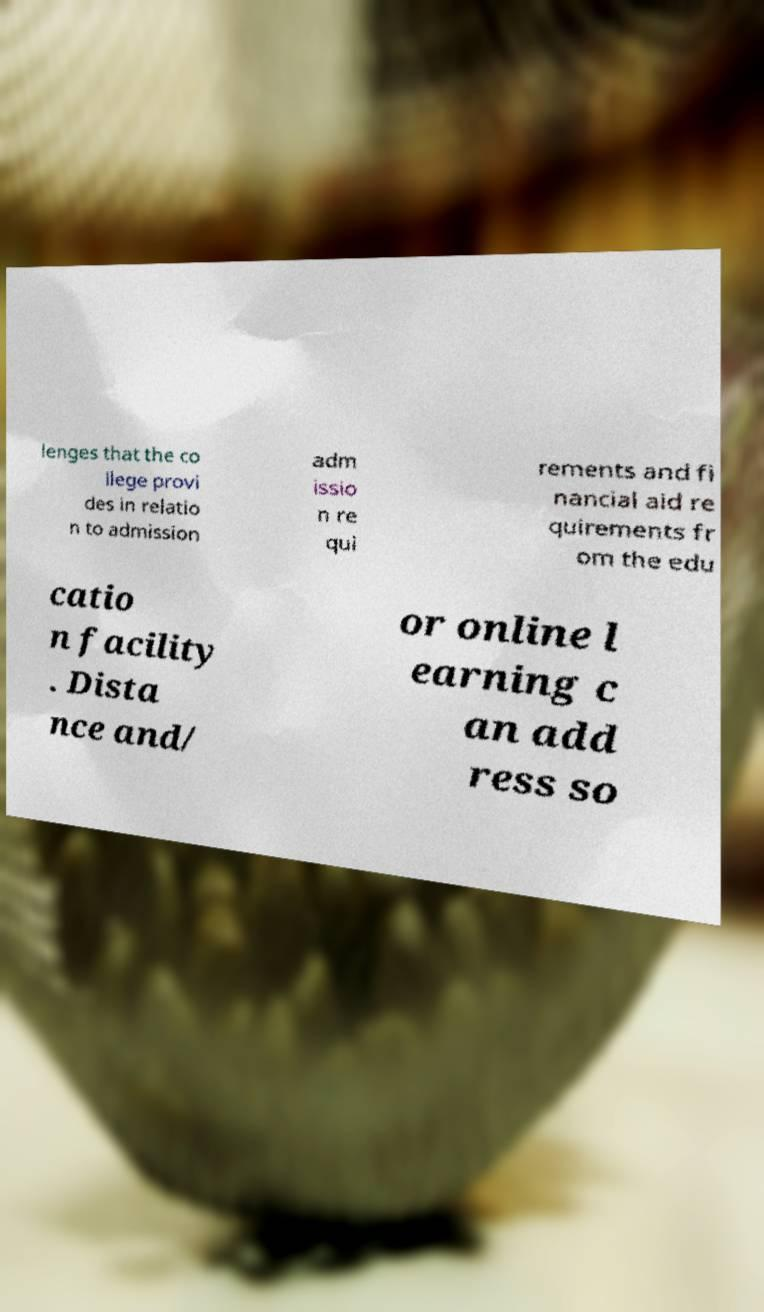I need the written content from this picture converted into text. Can you do that? lenges that the co llege provi des in relatio n to admission adm issio n re qui rements and fi nancial aid re quirements fr om the edu catio n facility . Dista nce and/ or online l earning c an add ress so 